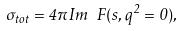Convert formula to latex. <formula><loc_0><loc_0><loc_500><loc_500>\sigma _ { t o t } = 4 \pi I m \ F ( s , q ^ { 2 } = 0 ) ,</formula> 